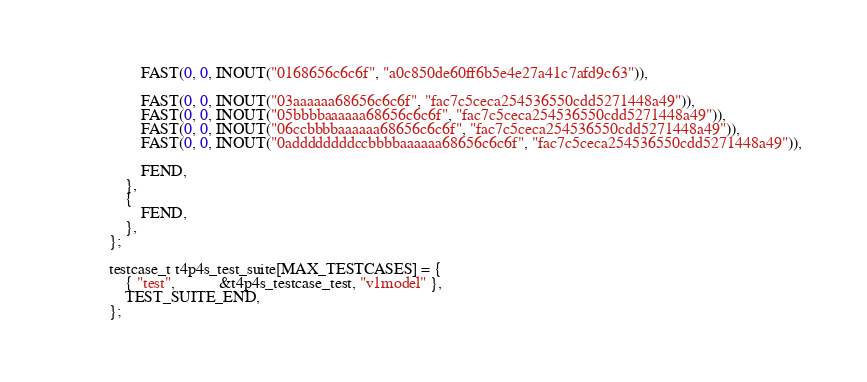<code> <loc_0><loc_0><loc_500><loc_500><_C_>        FAST(0, 0, INOUT("0168656c6c6f", "a0c850de60ff6b5e4e27a41c7afd9c63")),

        FAST(0, 0, INOUT("03aaaaaa68656c6c6f", "fac7c5ceca254536550cdd5271448a49")),
        FAST(0, 0, INOUT("05bbbbaaaaaa68656c6c6f", "fac7c5ceca254536550cdd5271448a49")),
        FAST(0, 0, INOUT("06ccbbbbaaaaaa68656c6c6f", "fac7c5ceca254536550cdd5271448a49")),
        FAST(0, 0, INOUT("0addddddddccbbbbaaaaaa68656c6c6f", "fac7c5ceca254536550cdd5271448a49")),
        
        FEND,
    },
    {
        FEND,
    },
};

testcase_t t4p4s_test_suite[MAX_TESTCASES] = {
    { "test",           &t4p4s_testcase_test, "v1model" },
    TEST_SUITE_END,
};
</code> 